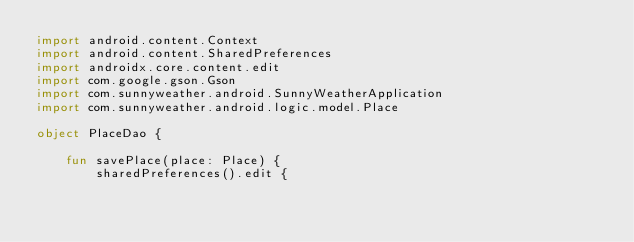Convert code to text. <code><loc_0><loc_0><loc_500><loc_500><_Kotlin_>import android.content.Context
import android.content.SharedPreferences
import androidx.core.content.edit
import com.google.gson.Gson
import com.sunnyweather.android.SunnyWeatherApplication
import com.sunnyweather.android.logic.model.Place

object PlaceDao {

    fun savePlace(place: Place) {
        sharedPreferences().edit {</code> 